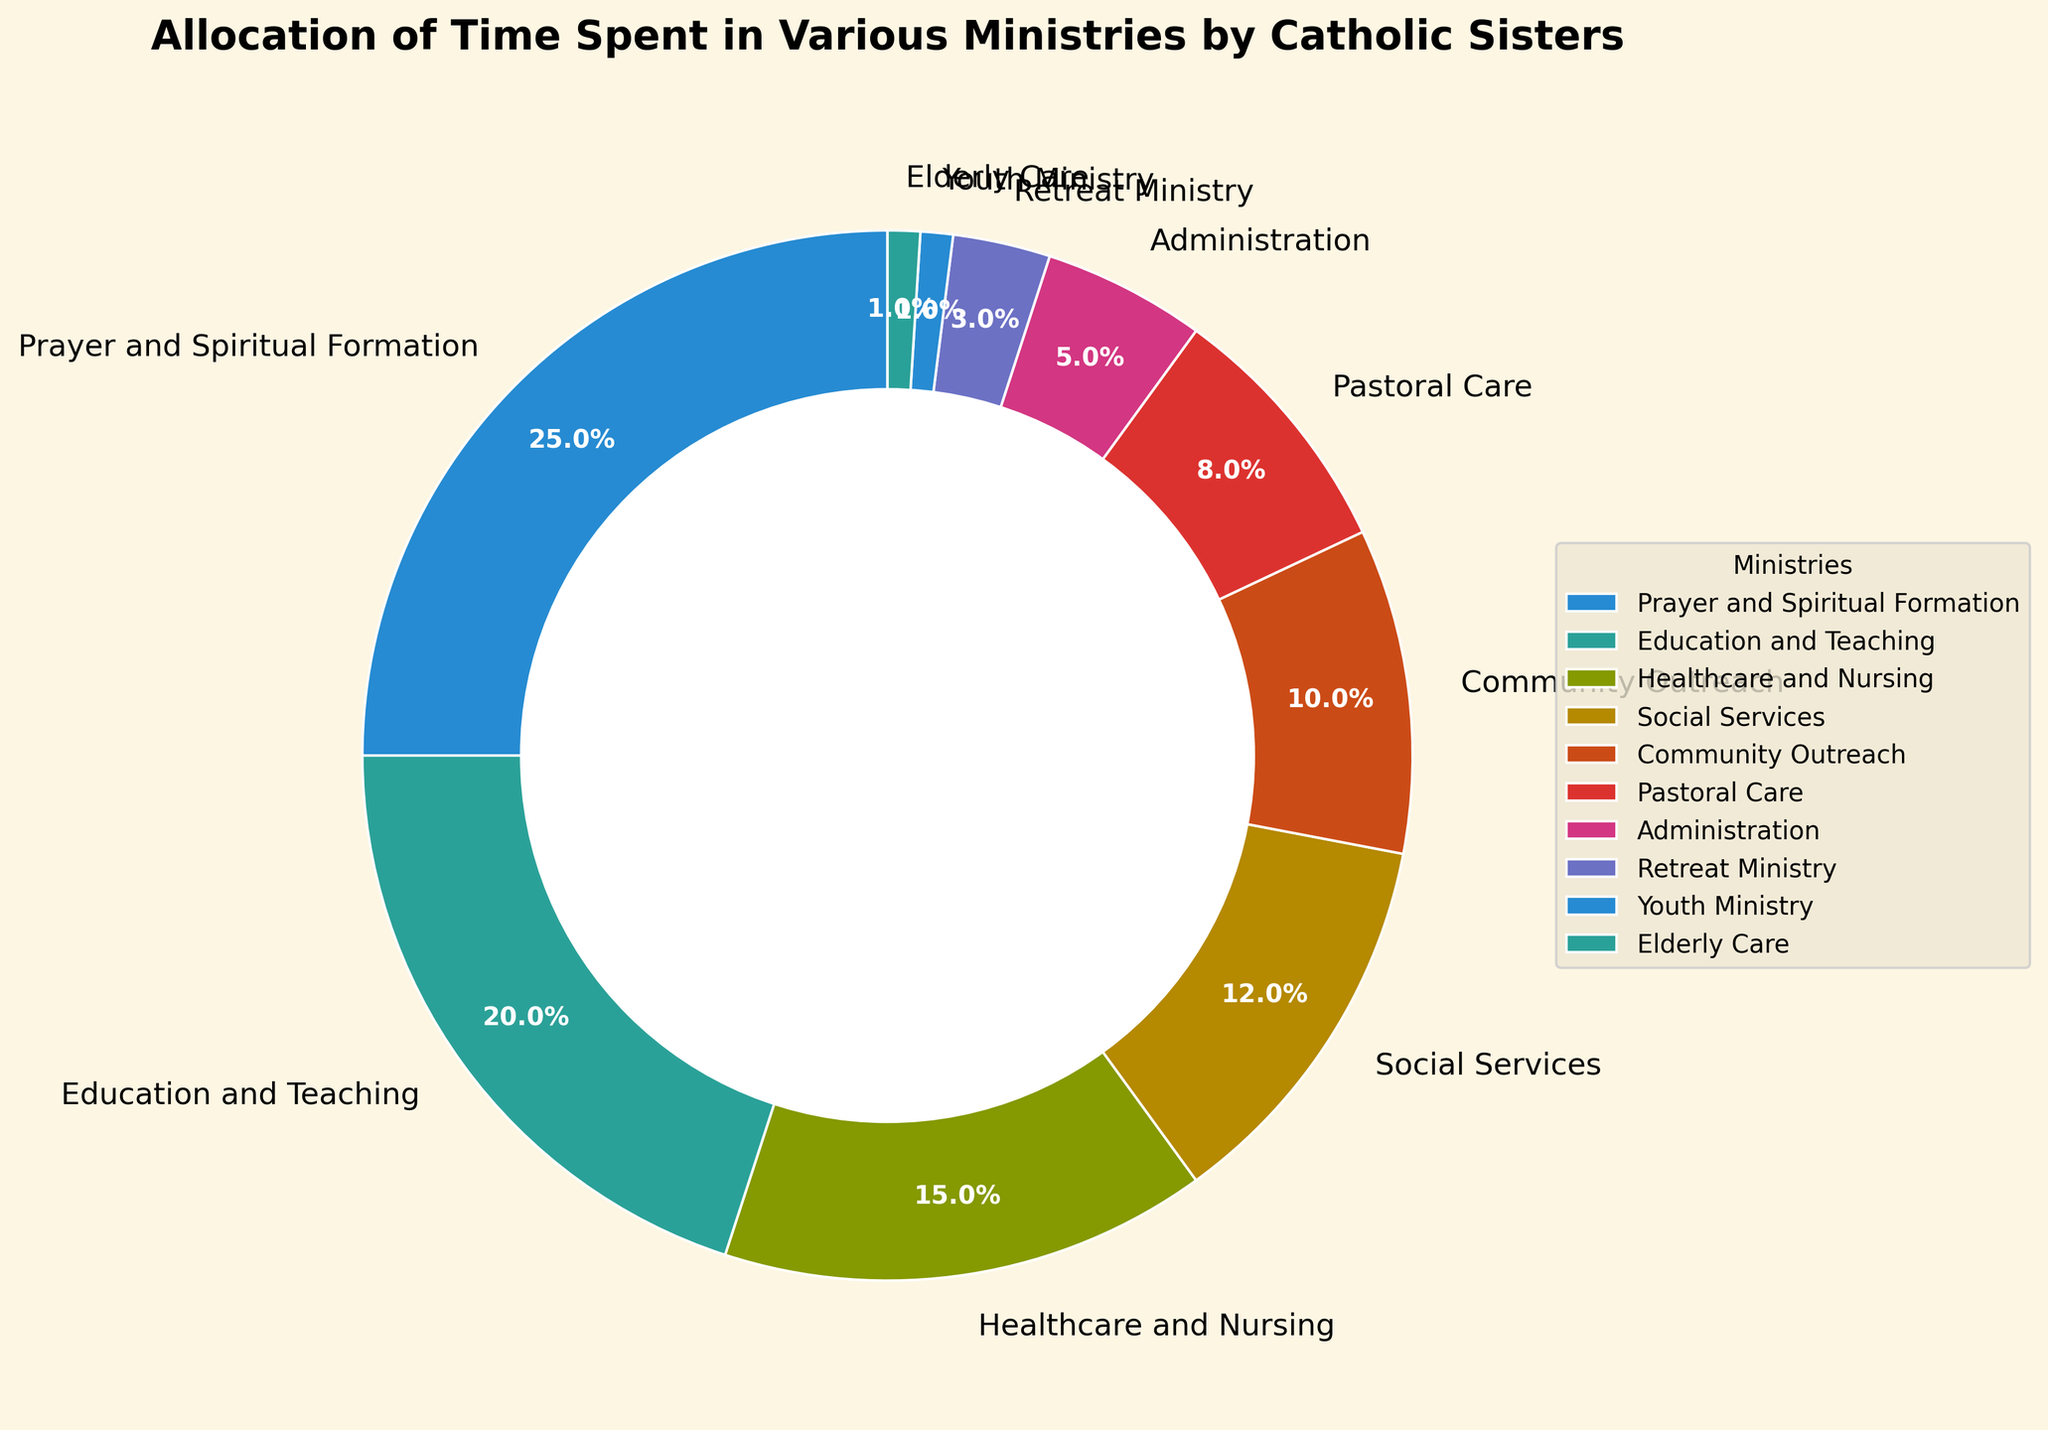Which ministry has the highest allocation of time? The pie chart shows that the largest segment represents Prayer and Spiritual Formation with 25%.
Answer: Prayer and Spiritual Formation What is the combined percentage for Education and Teaching and Healthcare and Nursing? Education and Teaching is 20% and Healthcare and Nursing is 15%, summing them gives 20 + 15 = 35%.
Answer: 35% Is the percentage spent on Social Services higher or lower than Community Outreach? The percentage spent on Social Services is 12%, which is higher than Community Outreach at 10%.
Answer: Higher How much more time do sisters allocate to Prayer and Spiritual Formation than to Administration? Prayer and Spiritual Formation is 25%, Administration is 5%. The difference is 25 - 5 = 20%.
Answer: 20% Which two ministries have the lowest allocation of time? The smallest segments in the pie chart are Youth Ministry and Elderly Care, both at 1%.
Answer: Youth Ministry and Elderly Care Between Pastoral Care and Retreat Ministry, which one receives a greater allocation of time and by how much? Pastoral Care receives 8% and Retreat Ministry receives 3%. The difference is 8 - 3 = 5%.
Answer: Pastoral Care by 5% What is the total percentage of time allocated to ministries with less than 10% allocation each? The ministries with less than 10% allocation are Community Outreach (10%), Pastoral Care (8%), Administration (5%), Retreat Ministry (3%), Youth Ministry (1%), and Elderly Care (1%). Their total percentage is 10 + 8 + 5 + 3 + 1 + 1 = 28%.
Answer: 28% Are there more ministries with a higher allocation of time than or equal to 10% than those below 10%? Ministries with ≥10% are Prayer and Spiritual Formation (25%), Education and Teaching (20%), Healthcare and Nursing (15%), Social Services (12%), and Community Outreach (10%), which makes 5 ministries. Ministries with <10% are Pastoral Care (8%), Administration (5%), Retreat Ministry (3%), Youth Ministry (1%), and Elderly Care (1%), also 5 ministries. Thus, they are equal.
Answer: Equal Which ministries collectively form exactly half of the pie chart? Prayer and Spiritual Formation (25%), Education and Teaching (20%), and Healthcare and Nursing (15%) together form 25 + 20 + 15 = 60%, not half. Since the exact combination required is not possible to visualize at this moment, a meticulous calculation shows the collective percentage for each possible set.
Answer: Not possible with given combinations 